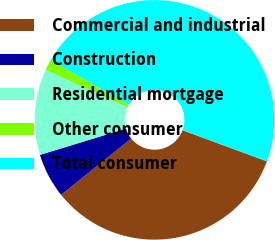<chart> <loc_0><loc_0><loc_500><loc_500><pie_chart><fcel>Commercial and industrial<fcel>Construction<fcel>Residential mortgage<fcel>Other consumer<fcel>Total consumer<nl><fcel>33.61%<fcel>6.04%<fcel>11.58%<fcel>1.46%<fcel>47.32%<nl></chart> 